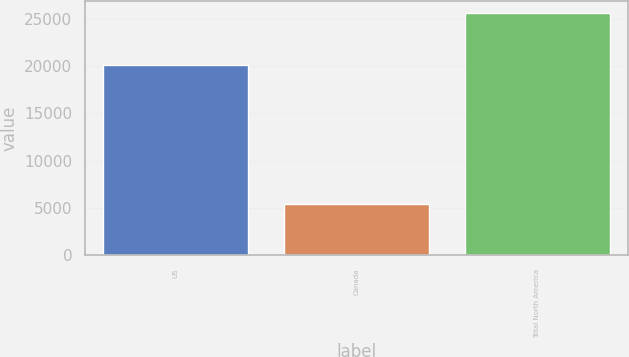Convert chart. <chart><loc_0><loc_0><loc_500><loc_500><bar_chart><fcel>US<fcel>Canada<fcel>Total North America<nl><fcel>20124<fcel>5444<fcel>25568<nl></chart> 